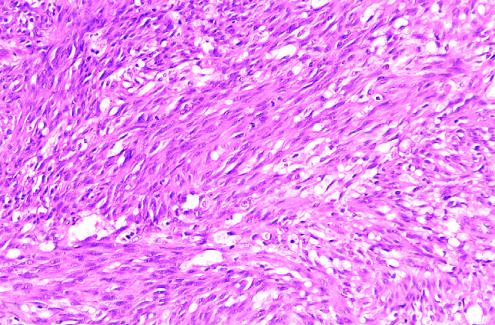what demonstrate sheets of plump, proliferating spindle cells and slitlike vascular spaces?
Answer the question using a single word or phrase. Histologic view of the nodular stage 